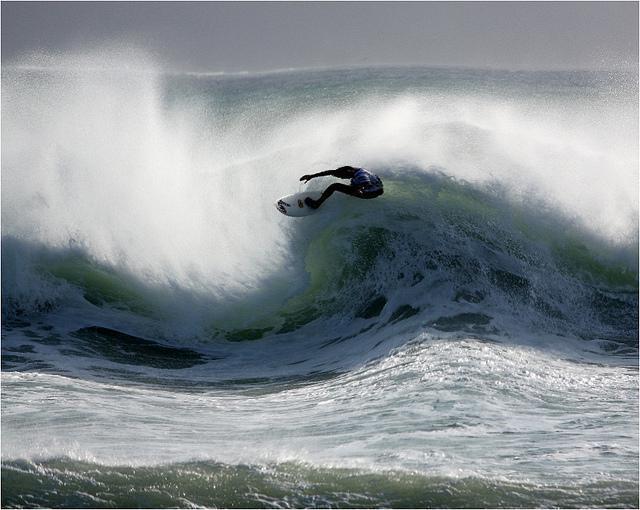How many of the motorcycles have a cover over part of the front wheel?
Give a very brief answer. 0. 